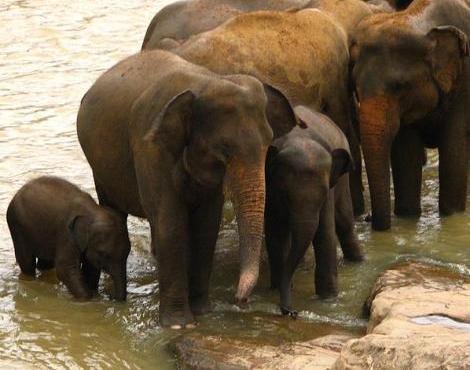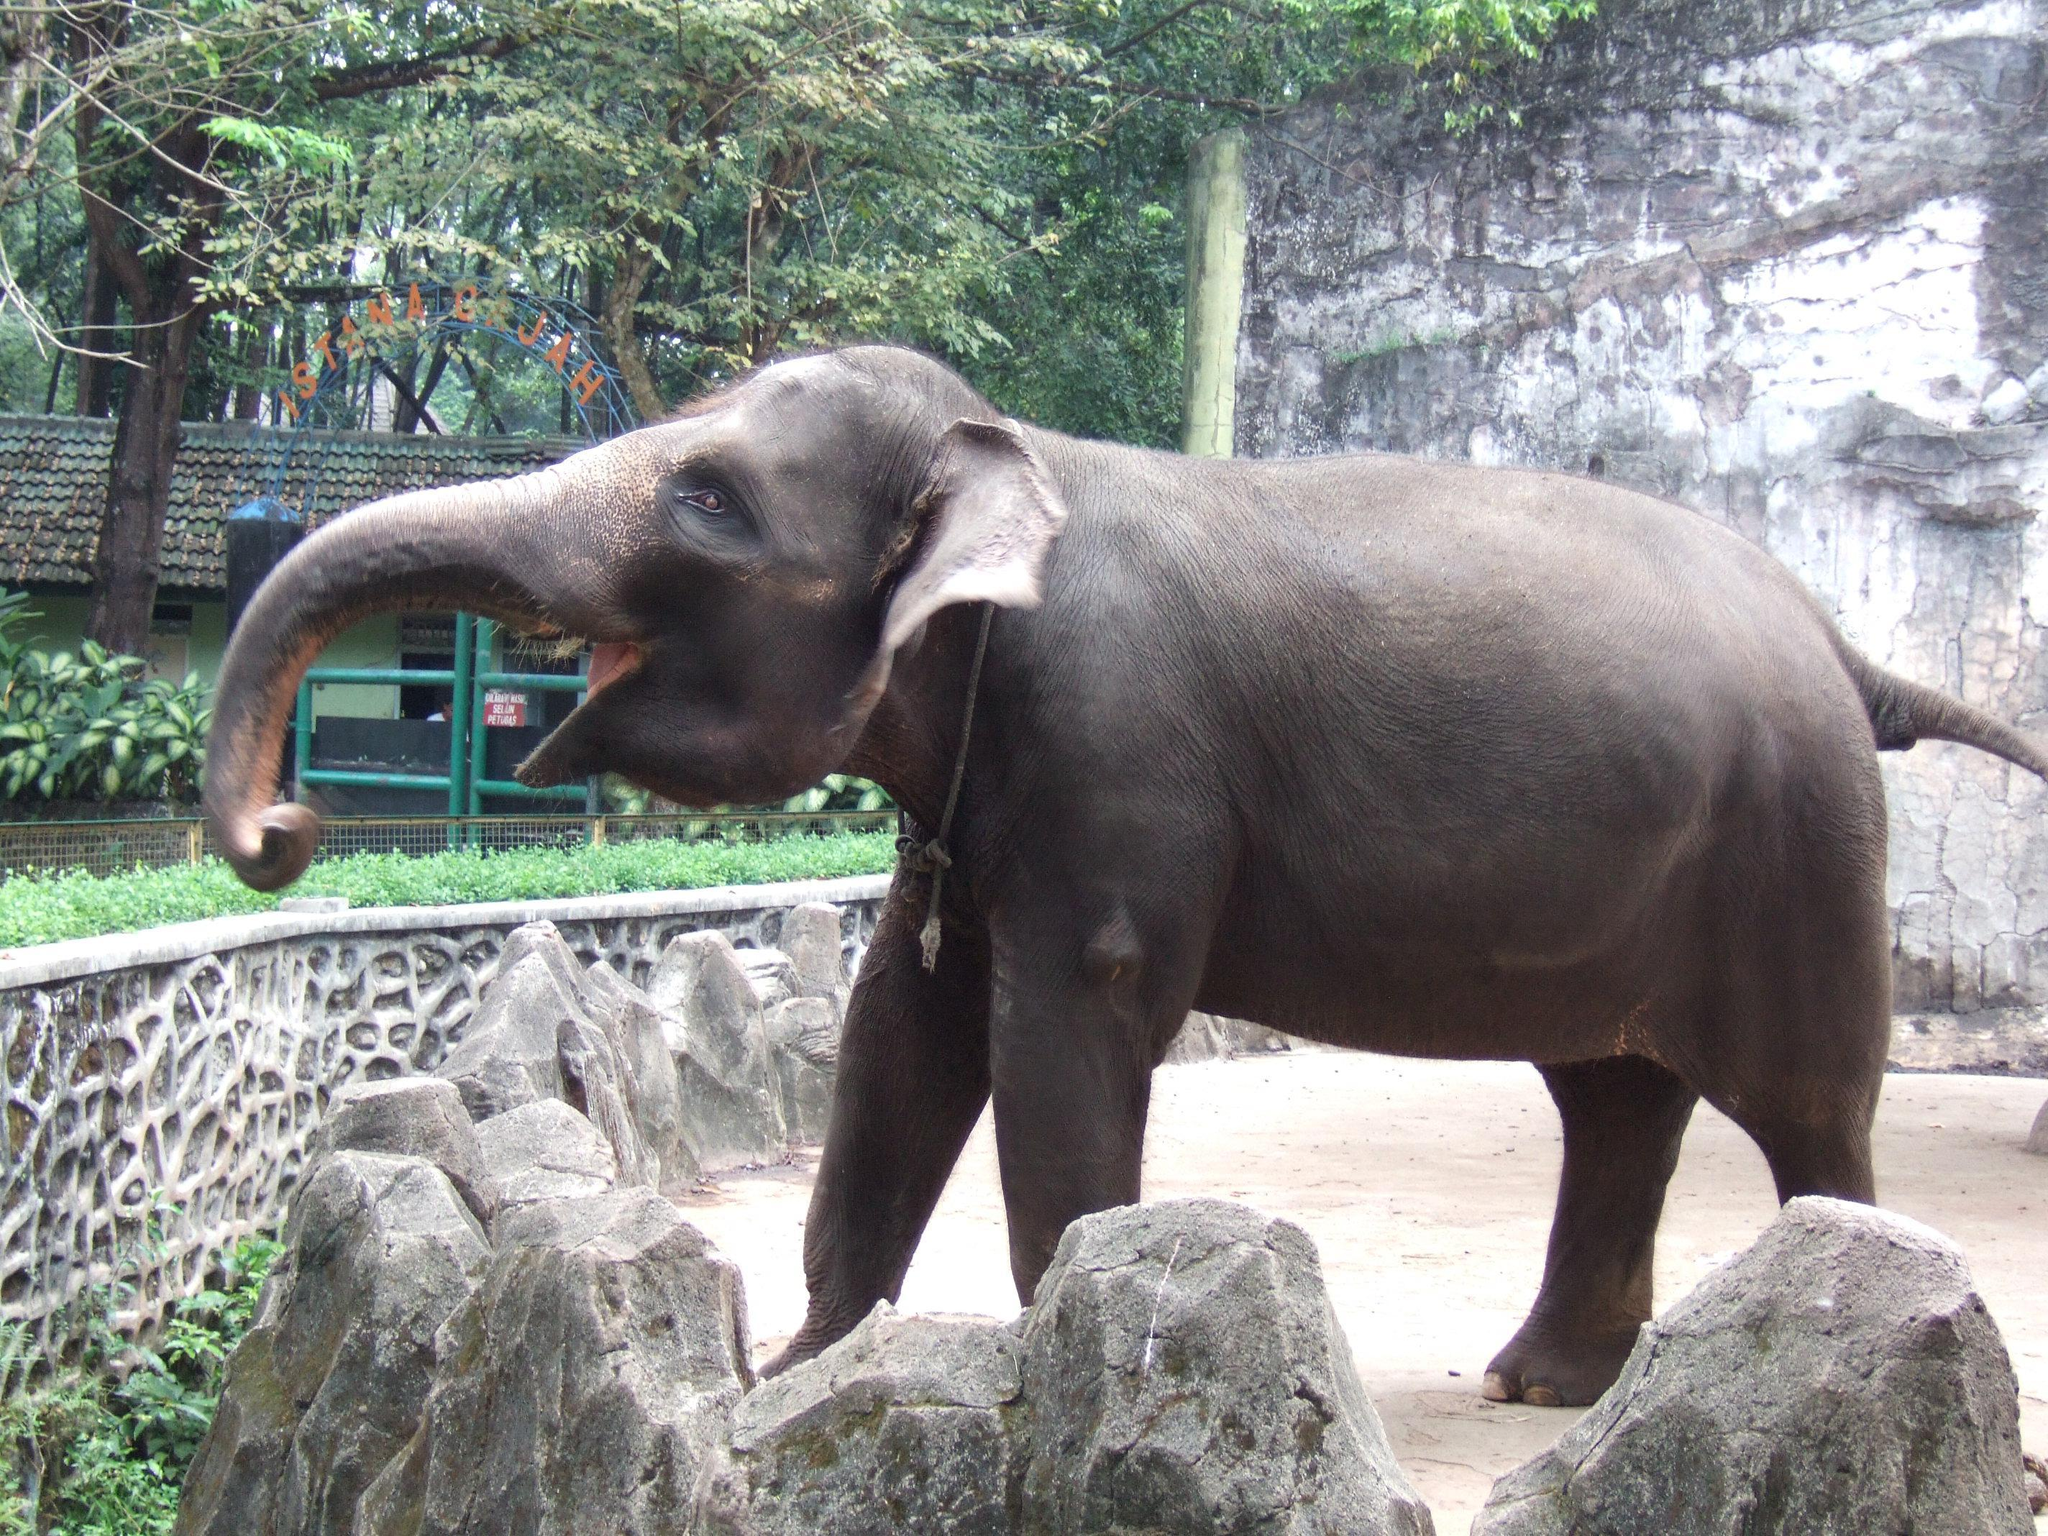The first image is the image on the left, the second image is the image on the right. Evaluate the accuracy of this statement regarding the images: "The elephant in the right image is facing towards the right.". Is it true? Answer yes or no. No. The first image is the image on the left, the second image is the image on the right. Evaluate the accuracy of this statement regarding the images: "An image shows one elephant standing on a surface surrounded by a curved raised edge.". Is it true? Answer yes or no. Yes. 